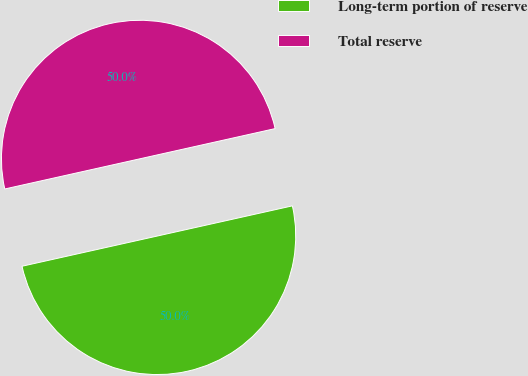Convert chart to OTSL. <chart><loc_0><loc_0><loc_500><loc_500><pie_chart><fcel>Long-term portion of reserve<fcel>Total reserve<nl><fcel>50.0%<fcel>50.0%<nl></chart> 